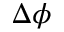<formula> <loc_0><loc_0><loc_500><loc_500>\Delta \phi</formula> 